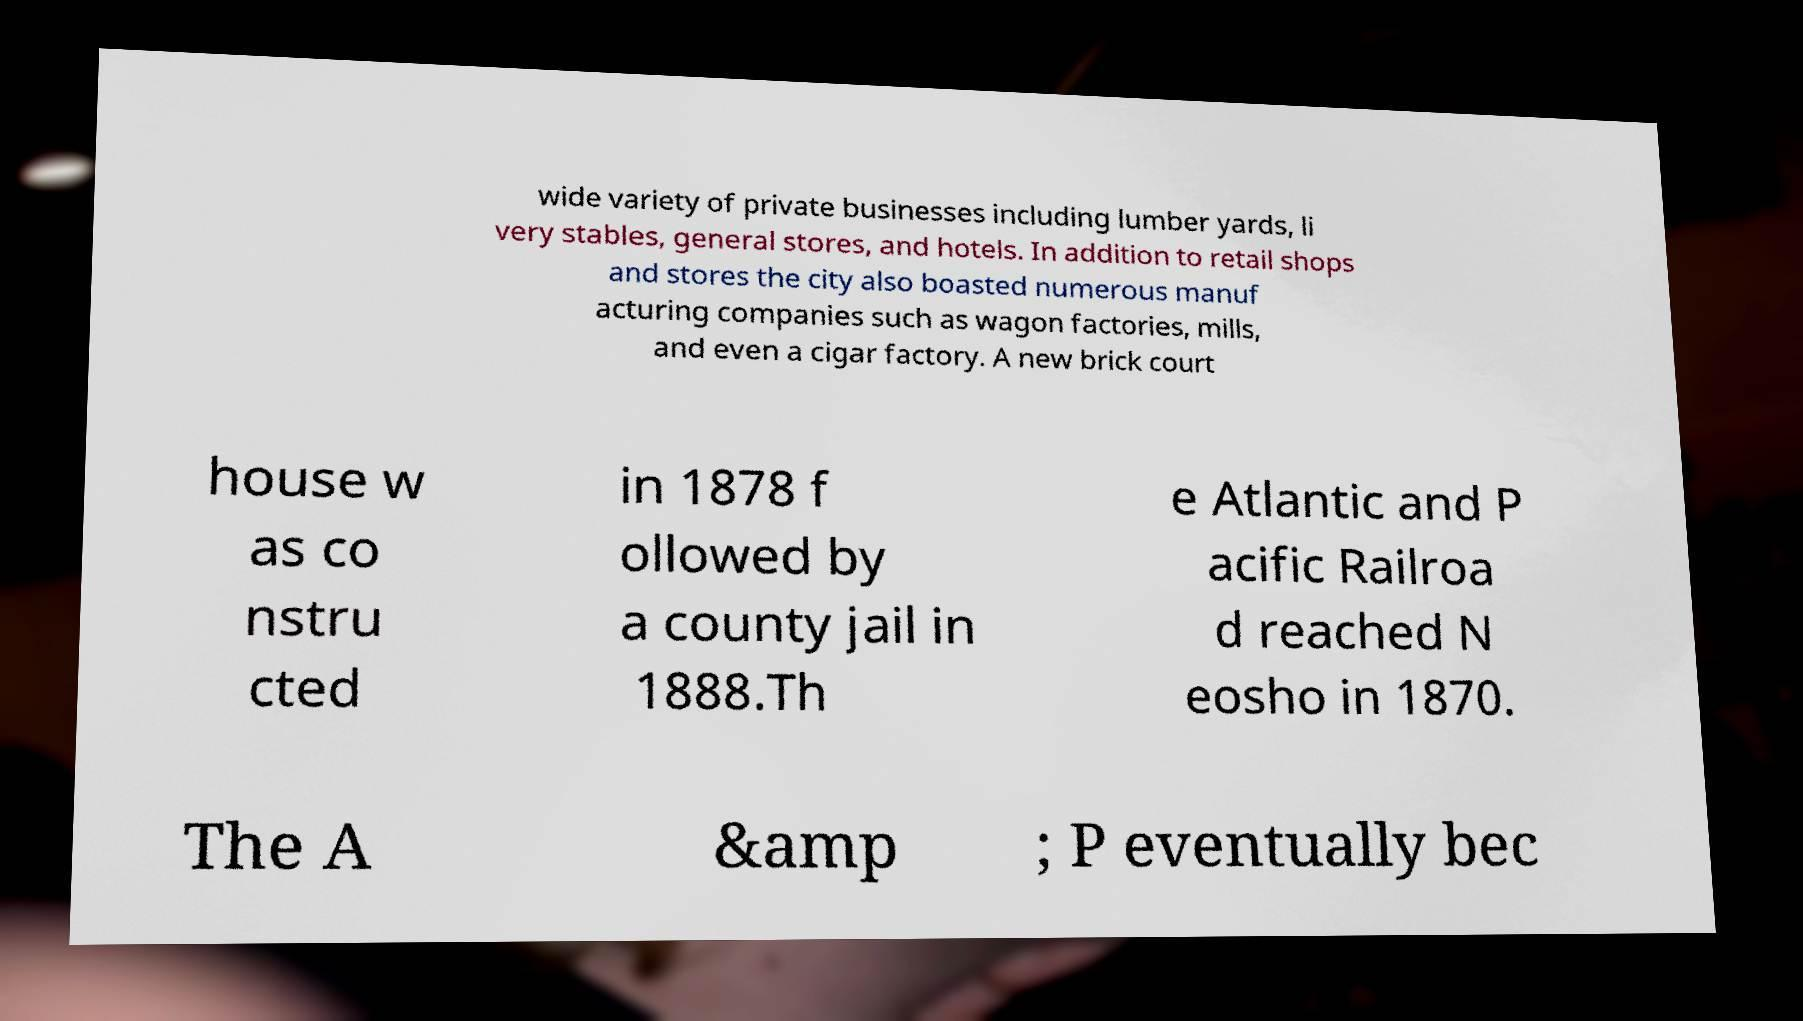Could you assist in decoding the text presented in this image and type it out clearly? wide variety of private businesses including lumber yards, li very stables, general stores, and hotels. In addition to retail shops and stores the city also boasted numerous manuf acturing companies such as wagon factories, mills, and even a cigar factory. A new brick court house w as co nstru cted in 1878 f ollowed by a county jail in 1888.Th e Atlantic and P acific Railroa d reached N eosho in 1870. The A &amp ; P eventually bec 